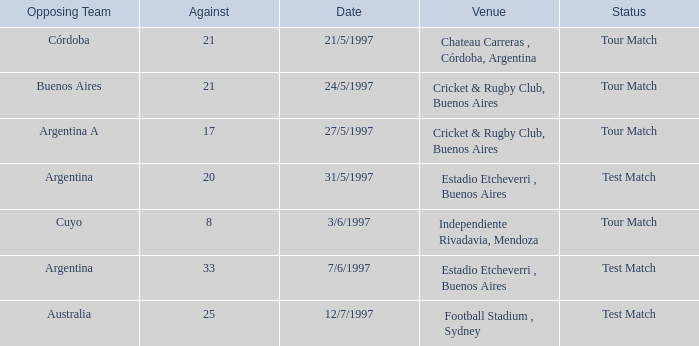What is the status of the match held on 12/7/1997? Test Match. 